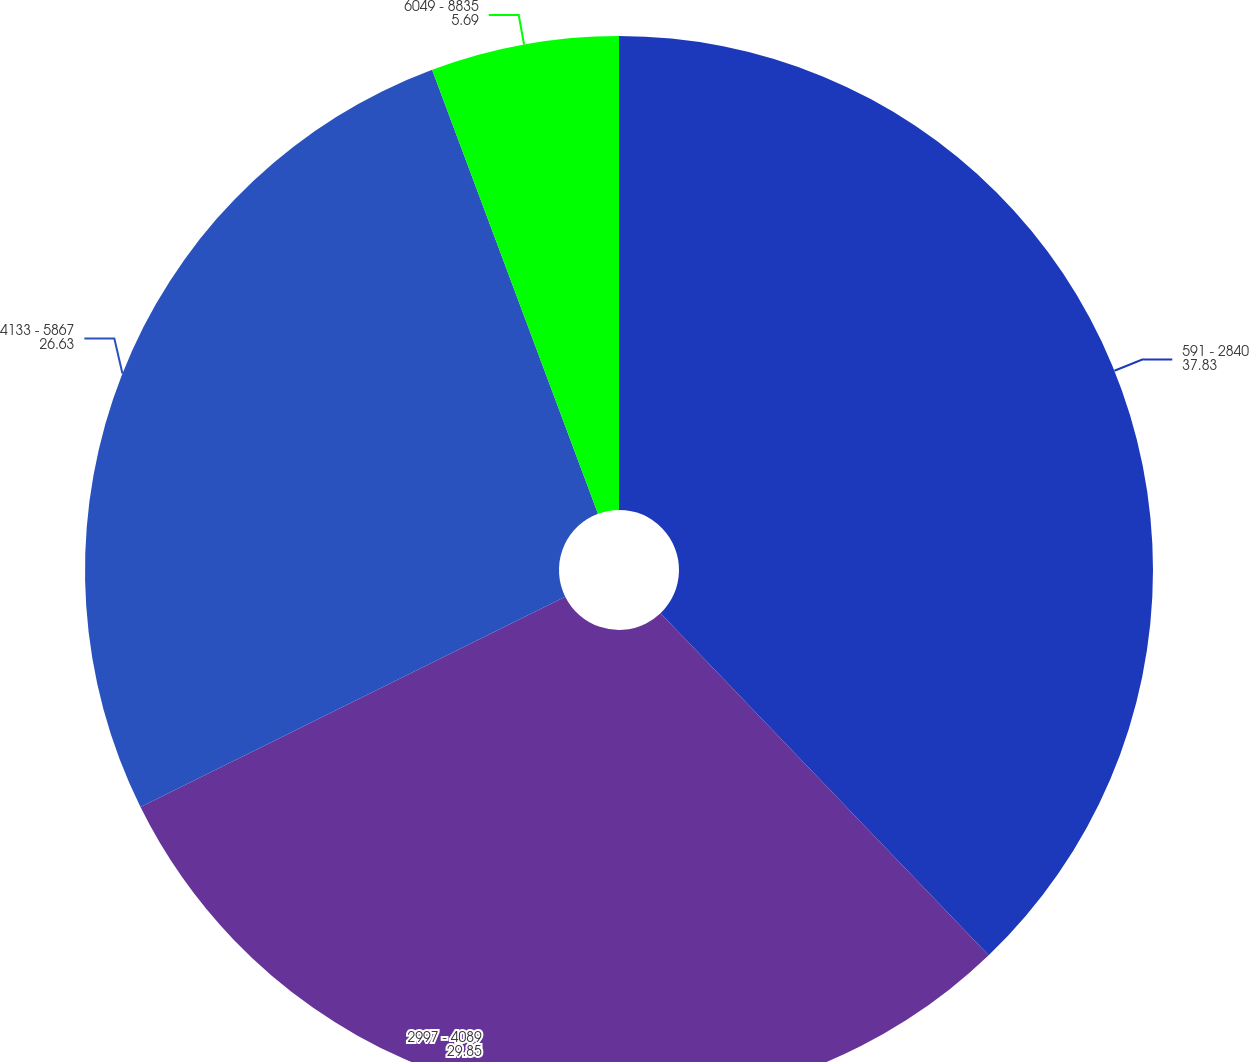<chart> <loc_0><loc_0><loc_500><loc_500><pie_chart><fcel>591 - 2840<fcel>2997 - 4089<fcel>4133 - 5867<fcel>6049 - 8835<nl><fcel>37.83%<fcel>29.85%<fcel>26.63%<fcel>5.69%<nl></chart> 